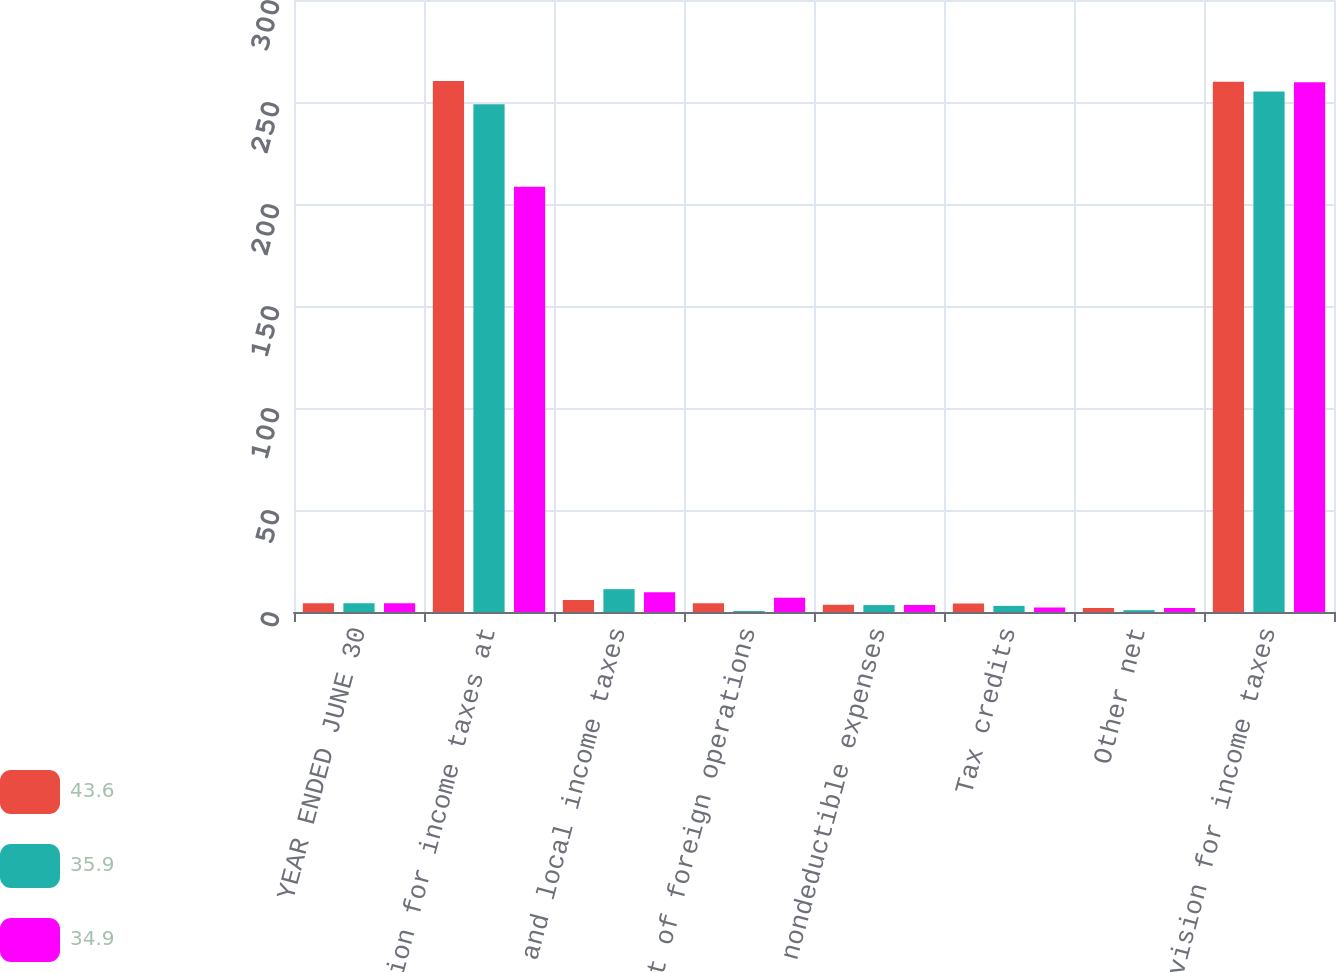Convert chart to OTSL. <chart><loc_0><loc_0><loc_500><loc_500><stacked_bar_chart><ecel><fcel>YEAR ENDED JUNE 30<fcel>Provision for income taxes at<fcel>State and local income taxes<fcel>Effect of foreign operations<fcel>Other nondeductible expenses<fcel>Tax credits<fcel>Other net<fcel>Provision for income taxes<nl><fcel>43.6<fcel>4.3<fcel>260.3<fcel>5.9<fcel>4.3<fcel>3.5<fcel>4.2<fcel>1.9<fcel>259.9<nl><fcel>35.9<fcel>4.3<fcel>248.9<fcel>11.2<fcel>0.5<fcel>3.4<fcel>3<fcel>0.9<fcel>255.2<nl><fcel>34.9<fcel>4.3<fcel>208.5<fcel>9.7<fcel>7<fcel>3.4<fcel>2.2<fcel>2<fcel>259.7<nl></chart> 